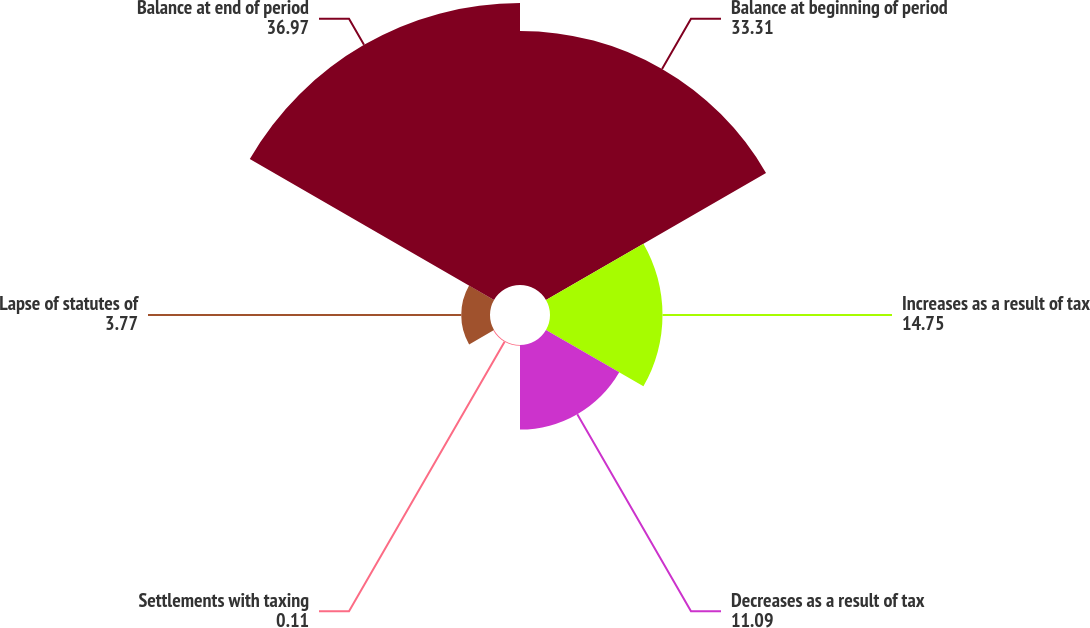Convert chart to OTSL. <chart><loc_0><loc_0><loc_500><loc_500><pie_chart><fcel>Balance at beginning of period<fcel>Increases as a result of tax<fcel>Decreases as a result of tax<fcel>Settlements with taxing<fcel>Lapse of statutes of<fcel>Balance at end of period<nl><fcel>33.31%<fcel>14.75%<fcel>11.09%<fcel>0.11%<fcel>3.77%<fcel>36.97%<nl></chart> 